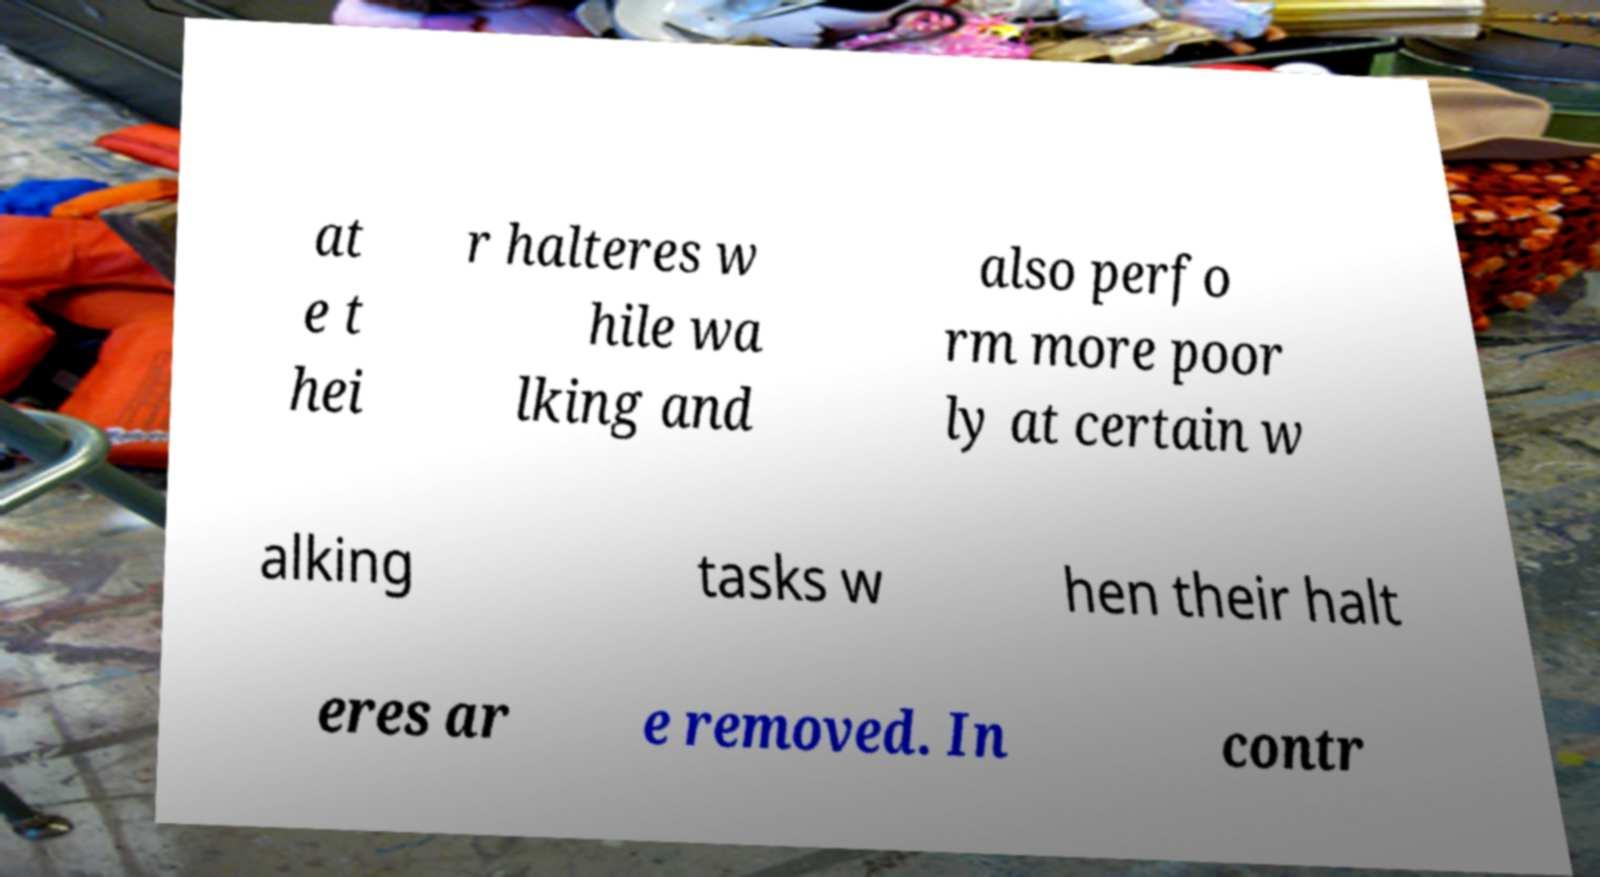Can you accurately transcribe the text from the provided image for me? at e t hei r halteres w hile wa lking and also perfo rm more poor ly at certain w alking tasks w hen their halt eres ar e removed. In contr 